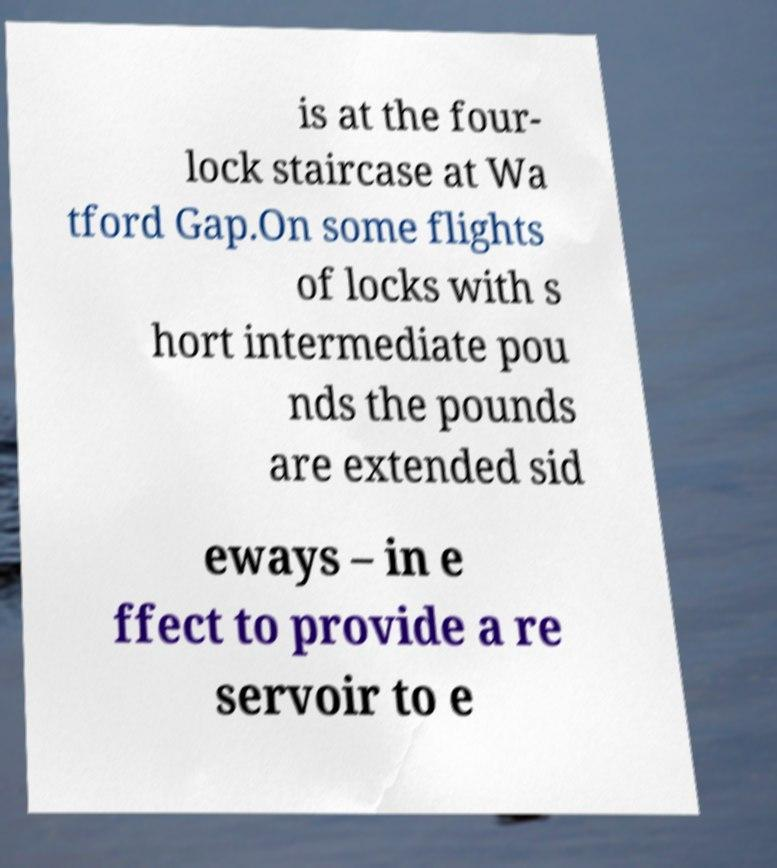For documentation purposes, I need the text within this image transcribed. Could you provide that? is at the four- lock staircase at Wa tford Gap.On some flights of locks with s hort intermediate pou nds the pounds are extended sid eways – in e ffect to provide a re servoir to e 